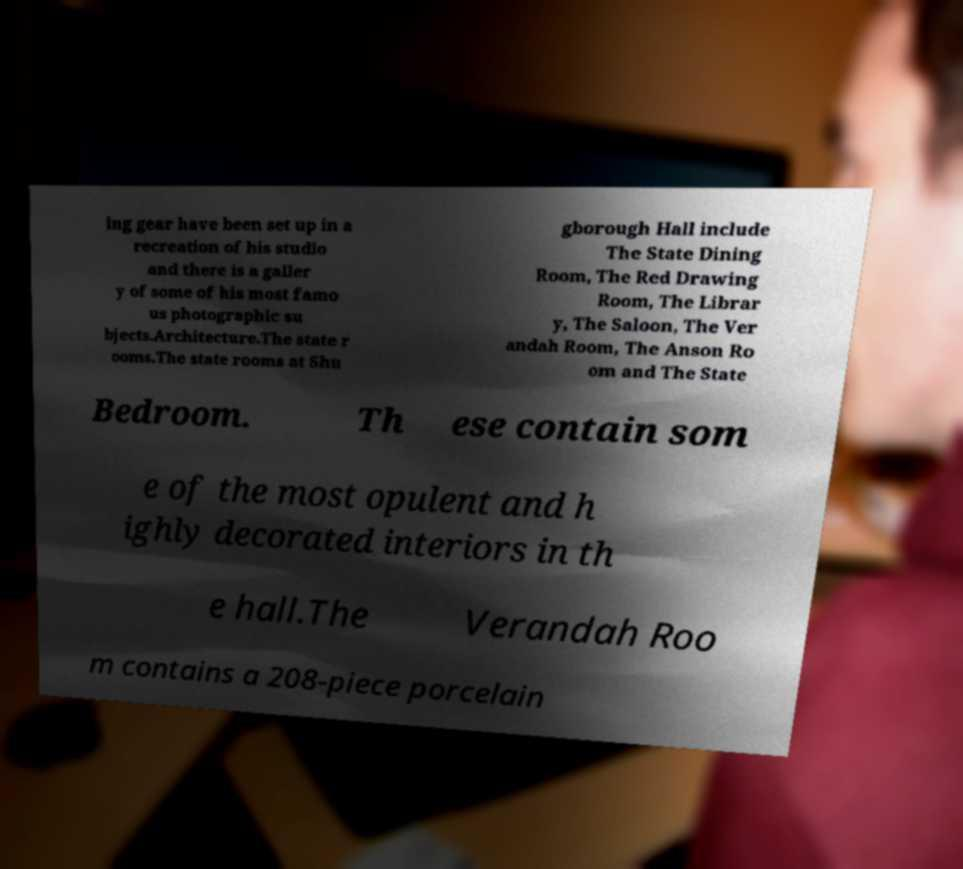Can you read and provide the text displayed in the image?This photo seems to have some interesting text. Can you extract and type it out for me? ing gear have been set up in a recreation of his studio and there is a galler y of some of his most famo us photographic su bjects.Architecture.The state r ooms.The state rooms at Shu gborough Hall include The State Dining Room, The Red Drawing Room, The Librar y, The Saloon, The Ver andah Room, The Anson Ro om and The State Bedroom. Th ese contain som e of the most opulent and h ighly decorated interiors in th e hall.The Verandah Roo m contains a 208-piece porcelain 